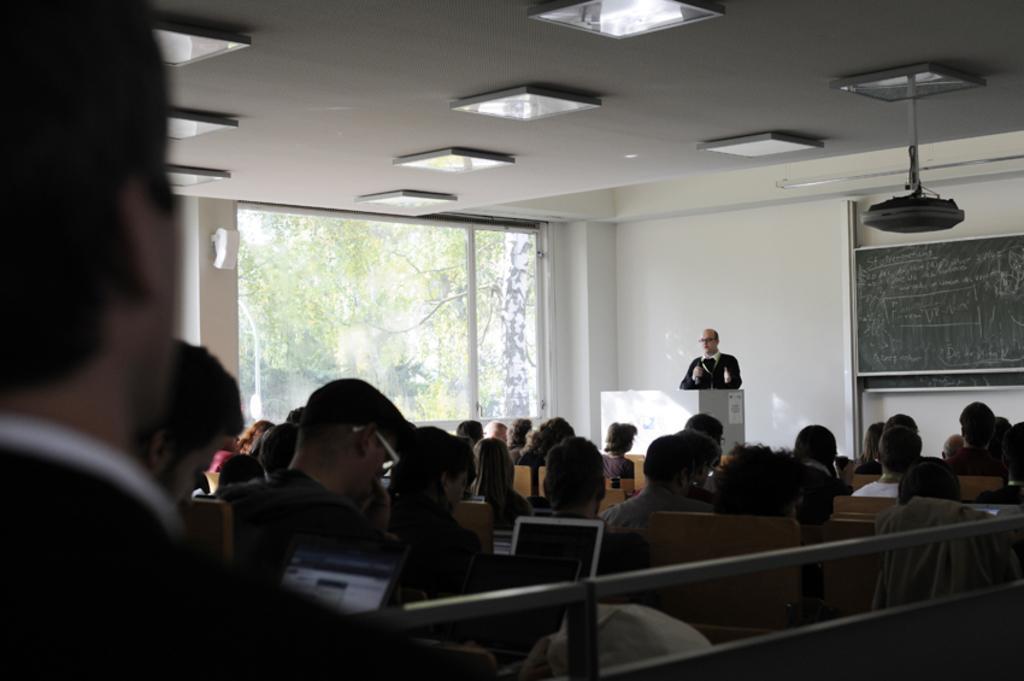How would you summarize this image in a sentence or two? There are people sitting in front of laptops in the foreground area of the image. There is a man standing in front of a desk, a board, window, lamps and trees in the background. 